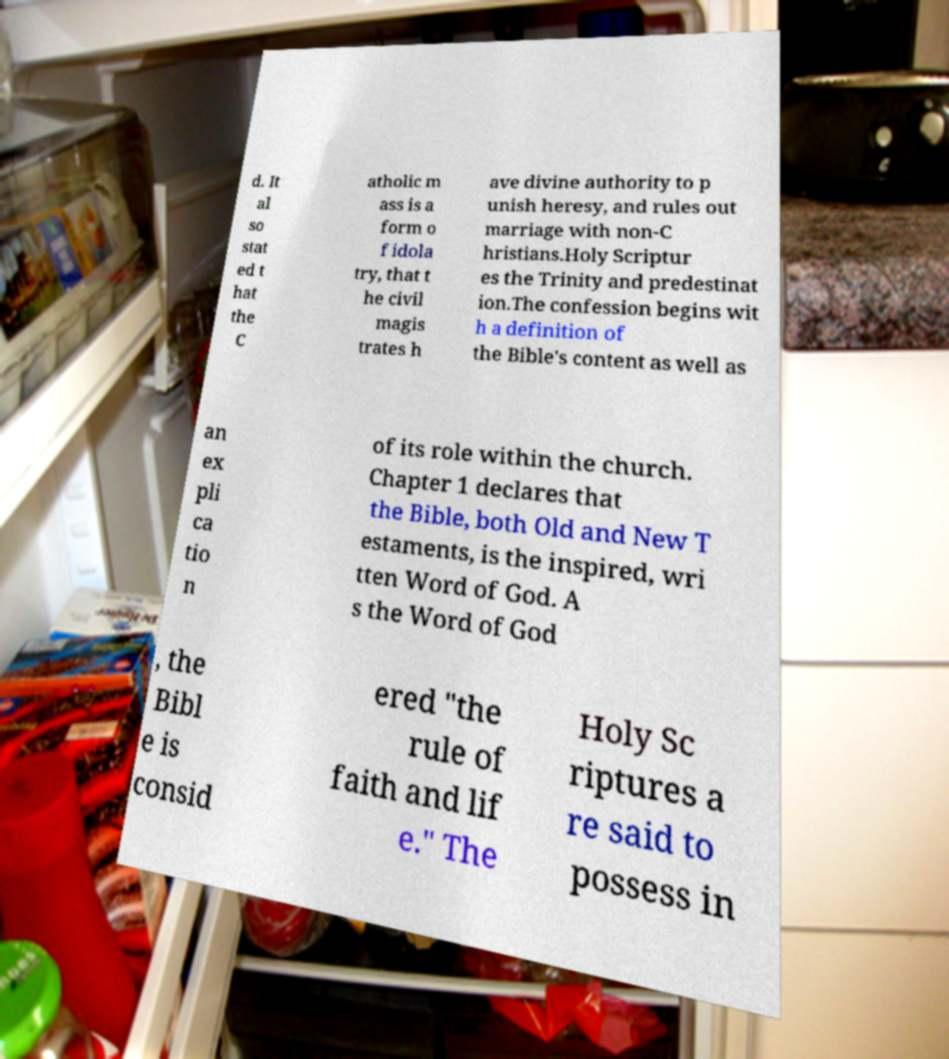Can you accurately transcribe the text from the provided image for me? d. It al so stat ed t hat the C atholic m ass is a form o f idola try, that t he civil magis trates h ave divine authority to p unish heresy, and rules out marriage with non-C hristians.Holy Scriptur es the Trinity and predestinat ion.The confession begins wit h a definition of the Bible's content as well as an ex pli ca tio n of its role within the church. Chapter 1 declares that the Bible, both Old and New T estaments, is the inspired, wri tten Word of God. A s the Word of God , the Bibl e is consid ered "the rule of faith and lif e." The Holy Sc riptures a re said to possess in 